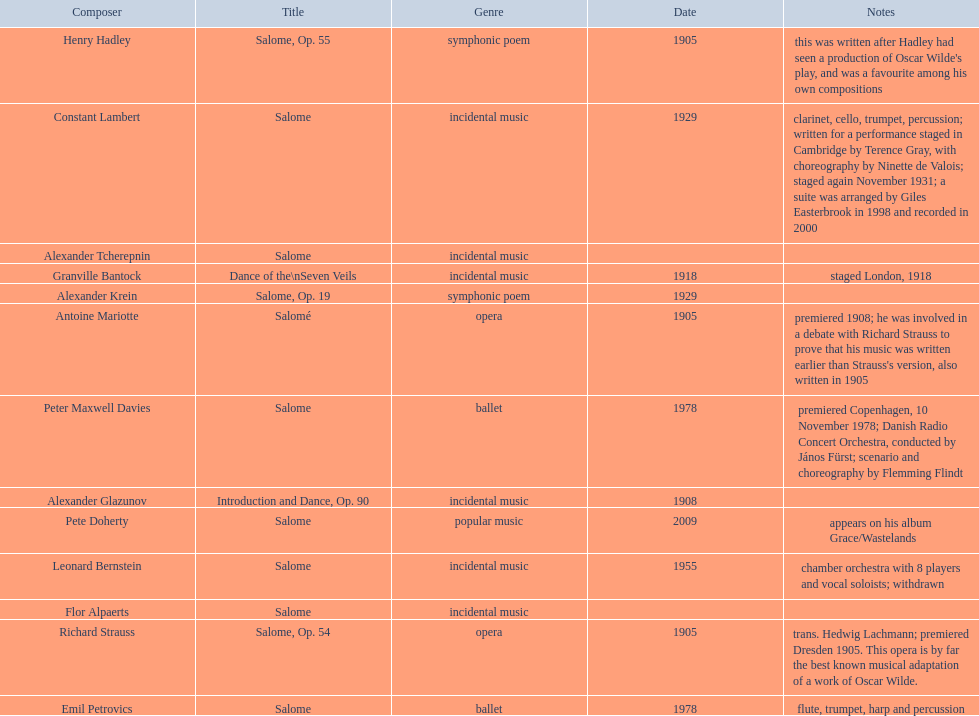Which composer is listed below pete doherty? Alexander Glazunov. 